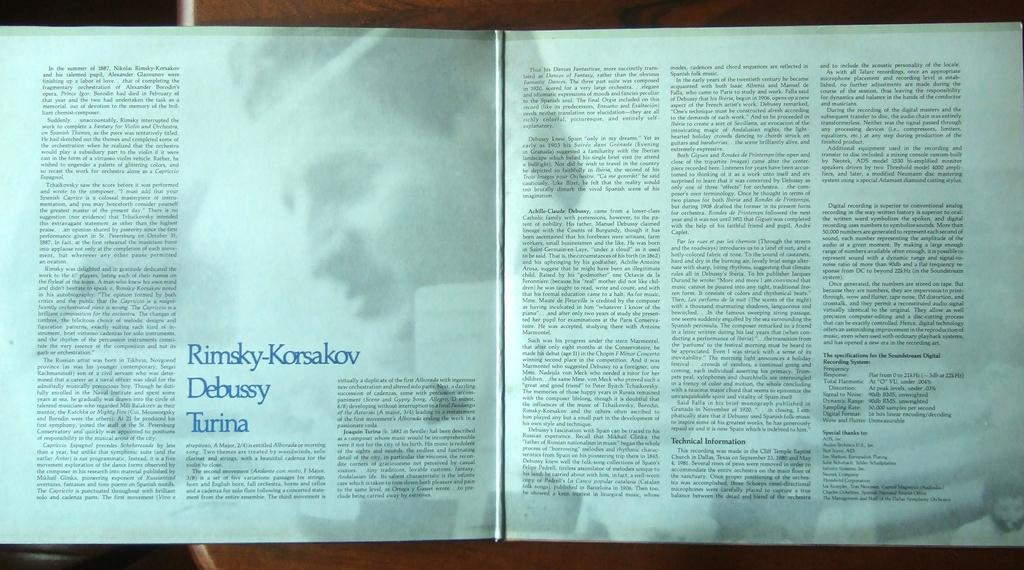<image>
Describe the image concisely. Open book on a page with blue letters that say "Rimsky-Korsakov" on it. 